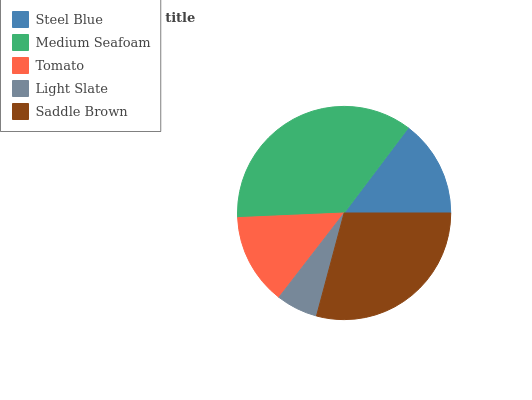Is Light Slate the minimum?
Answer yes or no. Yes. Is Medium Seafoam the maximum?
Answer yes or no. Yes. Is Tomato the minimum?
Answer yes or no. No. Is Tomato the maximum?
Answer yes or no. No. Is Medium Seafoam greater than Tomato?
Answer yes or no. Yes. Is Tomato less than Medium Seafoam?
Answer yes or no. Yes. Is Tomato greater than Medium Seafoam?
Answer yes or no. No. Is Medium Seafoam less than Tomato?
Answer yes or no. No. Is Steel Blue the high median?
Answer yes or no. Yes. Is Steel Blue the low median?
Answer yes or no. Yes. Is Saddle Brown the high median?
Answer yes or no. No. Is Saddle Brown the low median?
Answer yes or no. No. 